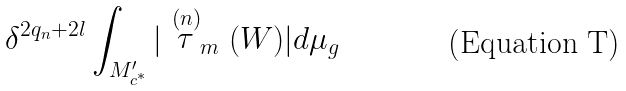<formula> <loc_0><loc_0><loc_500><loc_500>\delta ^ { 2 q _ { n } + 2 l } \int _ { M ^ { \prime } _ { c ^ { * } } } | \stackrel { ( n ) } { \tau } _ { m } ( W ) | d \mu _ { g }</formula> 